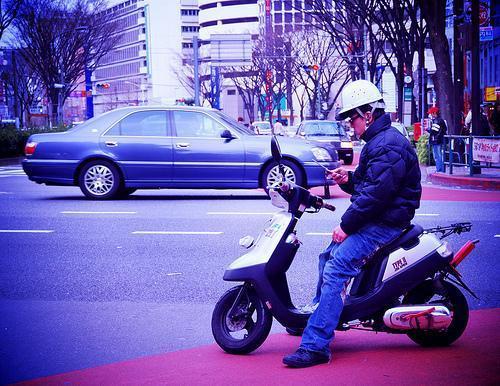How many scooters are there?
Give a very brief answer. 1. 